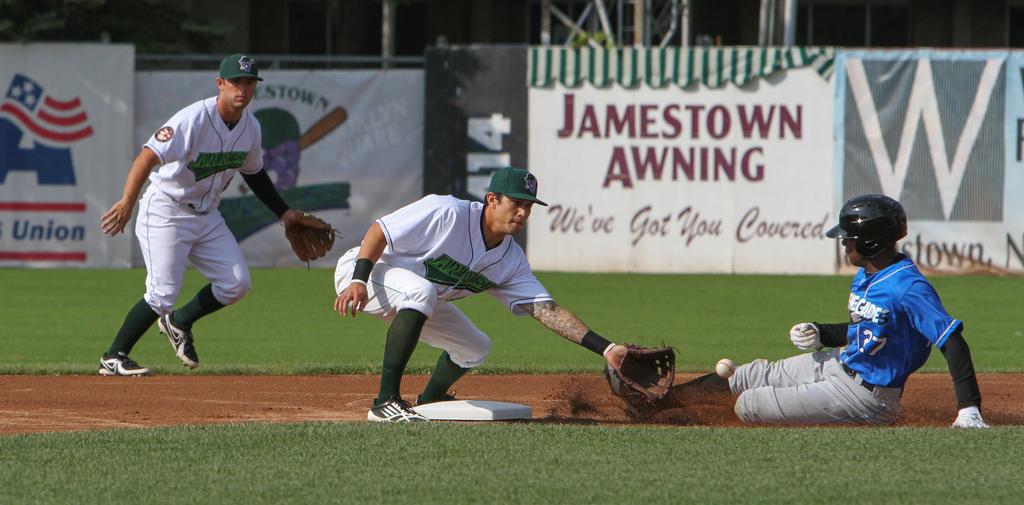Who is advertising in the background?
Provide a succinct answer. Jamestown awning. What is the motto written on the jamestown awning ad?
Provide a short and direct response. We've got you covered. 